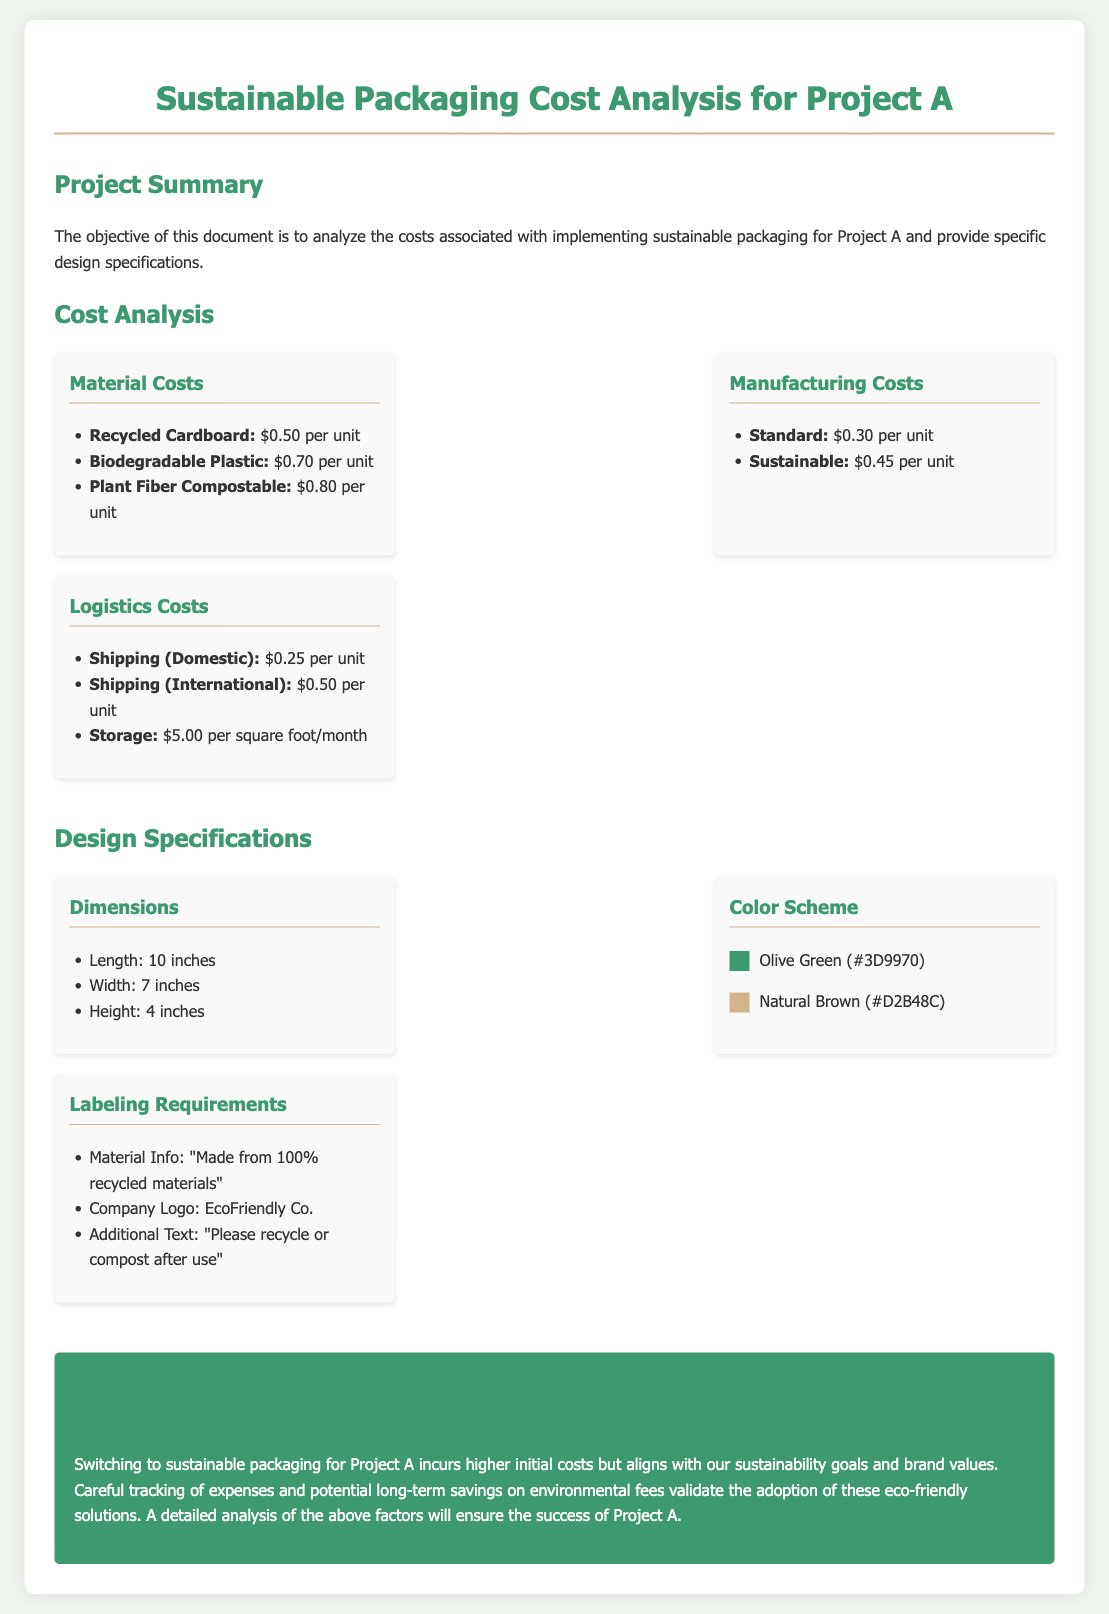What are the material costs? The document lists the costs of materials as recycled cardboard for $0.50 per unit, biodegradable plastic for $0.70 per unit, and plant fiber compostable for $0.80 per unit.
Answer: $0.50 per unit, $0.70 per unit, $0.80 per unit What is the size of the packaging? The dimensions of the packaging provided in the design specifications are length, width, and height.
Answer: 10 inches, 7 inches, 4 inches What is the shipping cost for domestic? The document states the cost of shipping domestically as part of logistics costs.
Answer: $0.25 per unit What color is specified for the packaging? The color scheme includes specific colors, with Olive Green and Natural Brown being mentioned.
Answer: Olive Green, Natural Brown What is the initial cost difference between sustainable and standard manufacturing? The costs are differentiated in the analysis to show the difference between the two manufacturing processes.
Answer: $0.15 per unit What labeling text is required? The document specifies the labeling requirements including a phrase about recycling and the company logo.
Answer: "Made from 100% recycled materials", EcoFriendly Co., "Please recycle or compost after use" What is the conclusion regarding sustainable packaging costs? The conclusion summarizes the evaluation of costs associated with sustainable packaging for Project A and their implications.
Answer: Higher initial costs but alignment with sustainability goals What is the logistics cost for international shipping? The analysis lists international shipping costs as part of the logistics section.
Answer: $0.50 per unit What is the manufacturing cost for sustainable packaging? The manufacturing costs for sustainable packaging are outlined in the document regarding production processes.
Answer: $0.45 per unit 